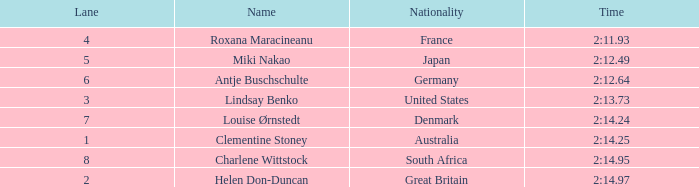What is the number of lane with a rank more than 2 for louise ørnstedt? 1.0. 